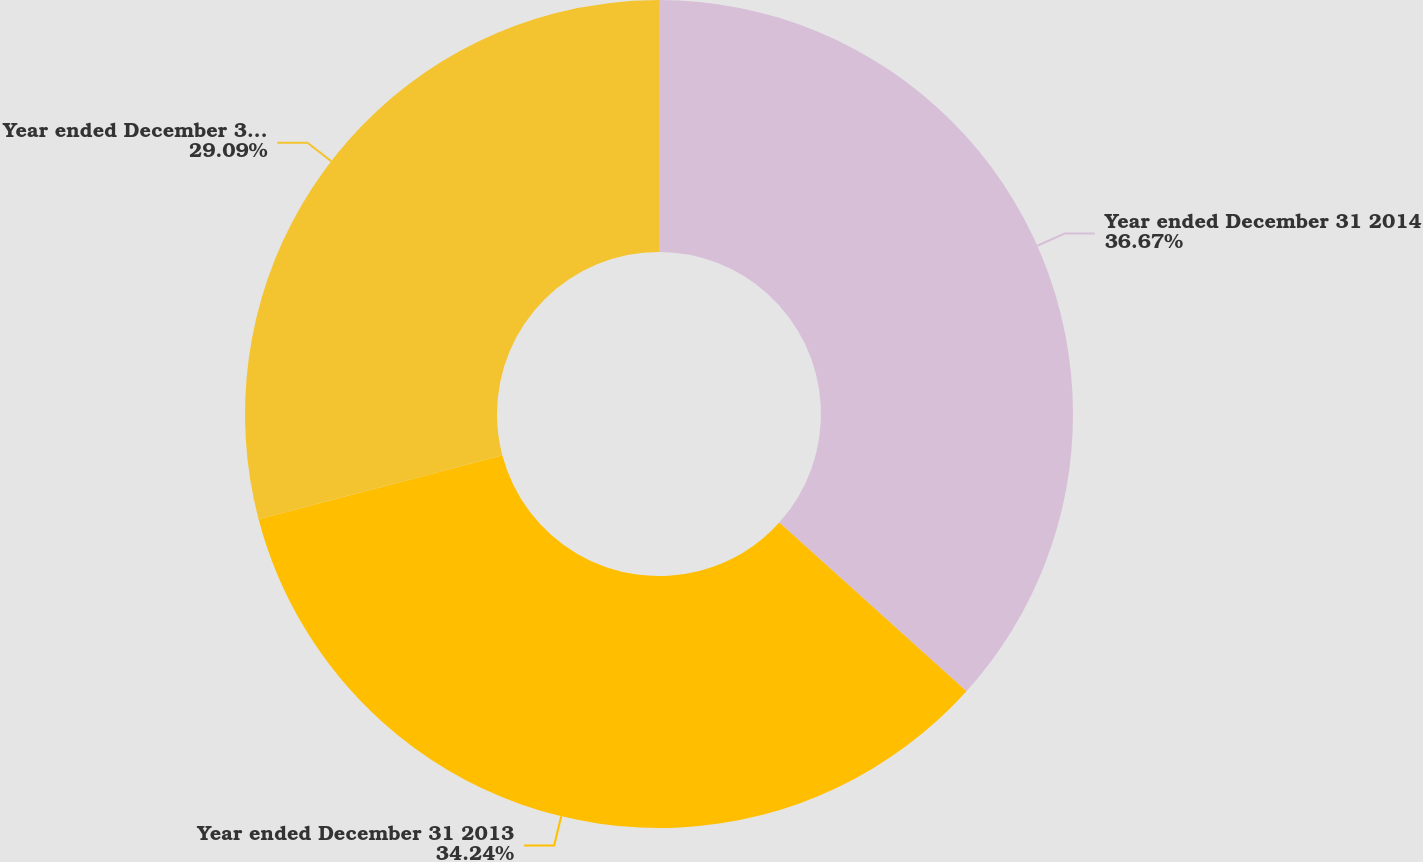<chart> <loc_0><loc_0><loc_500><loc_500><pie_chart><fcel>Year ended December 31 2014<fcel>Year ended December 31 2013<fcel>Year ended December 31 2012<nl><fcel>36.68%<fcel>34.24%<fcel>29.09%<nl></chart> 